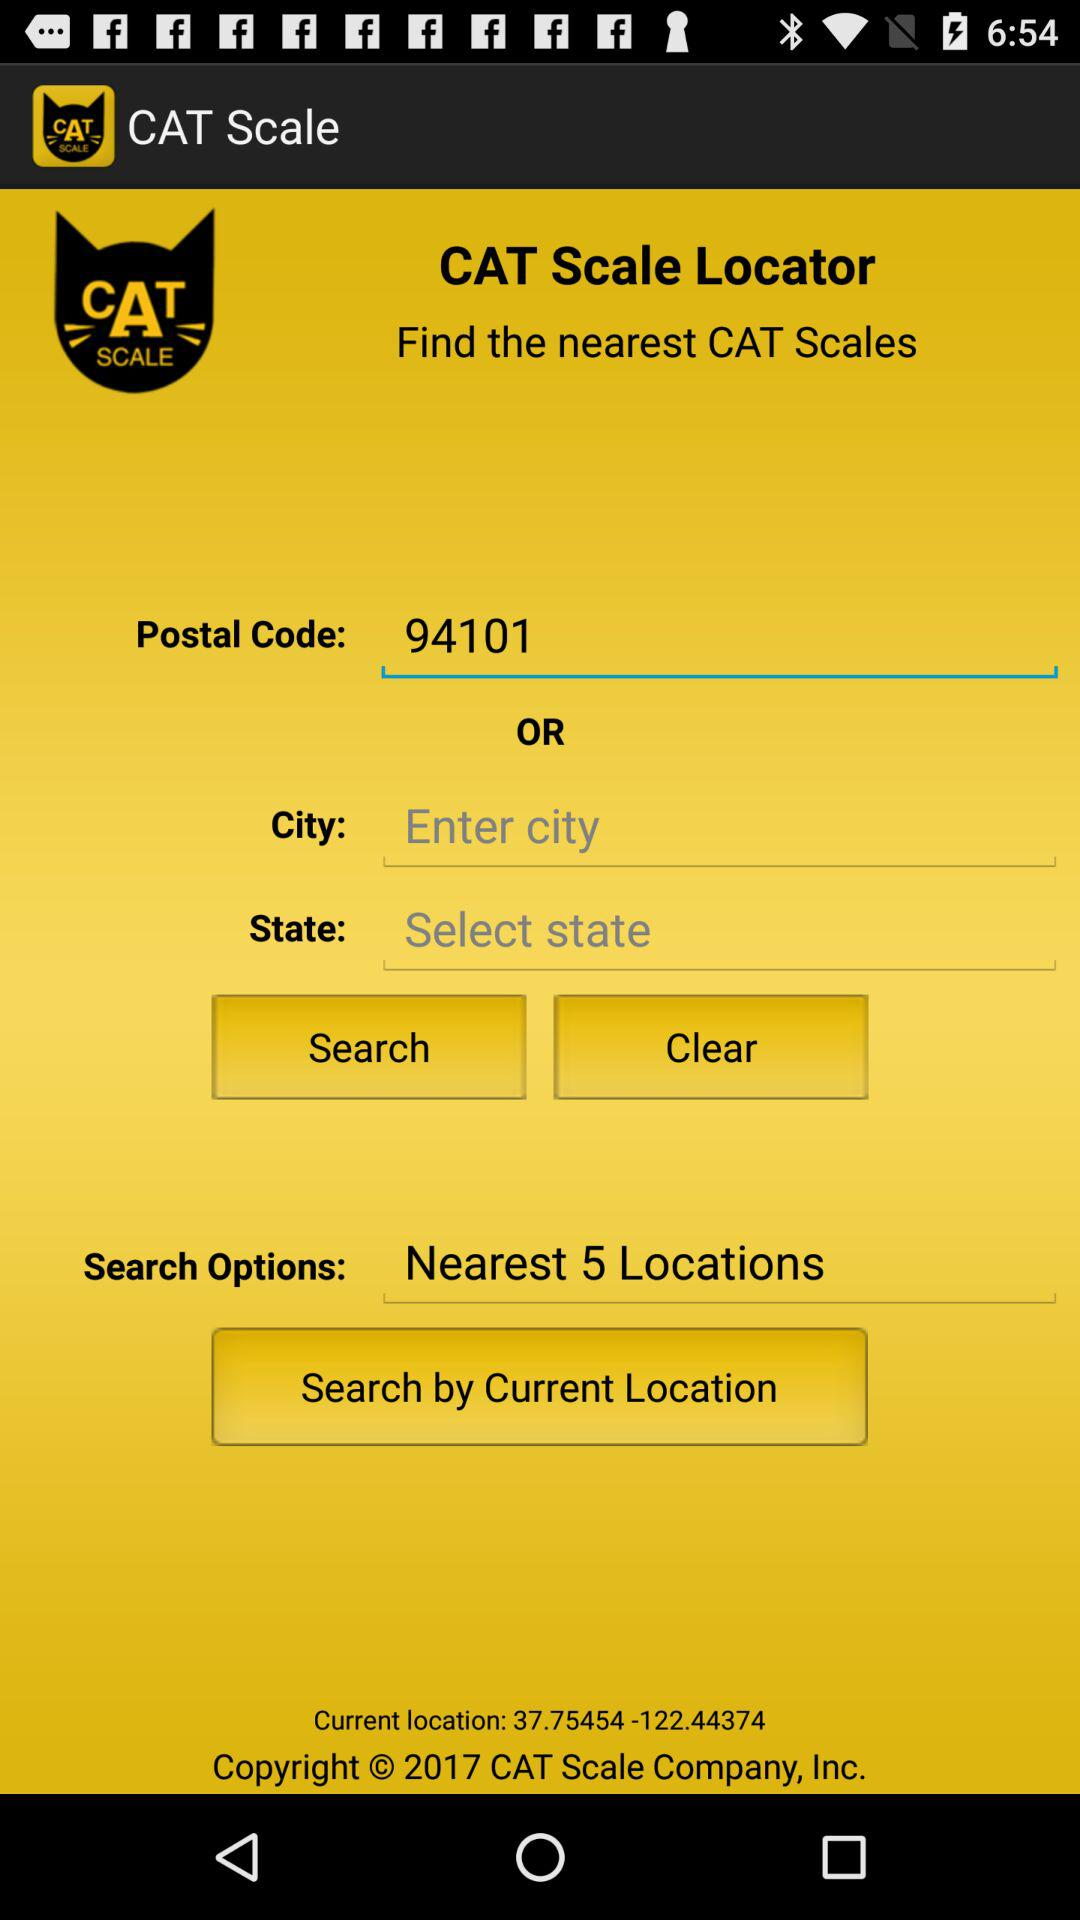What is the name of the application? The name of the application is "Cat Scale". 